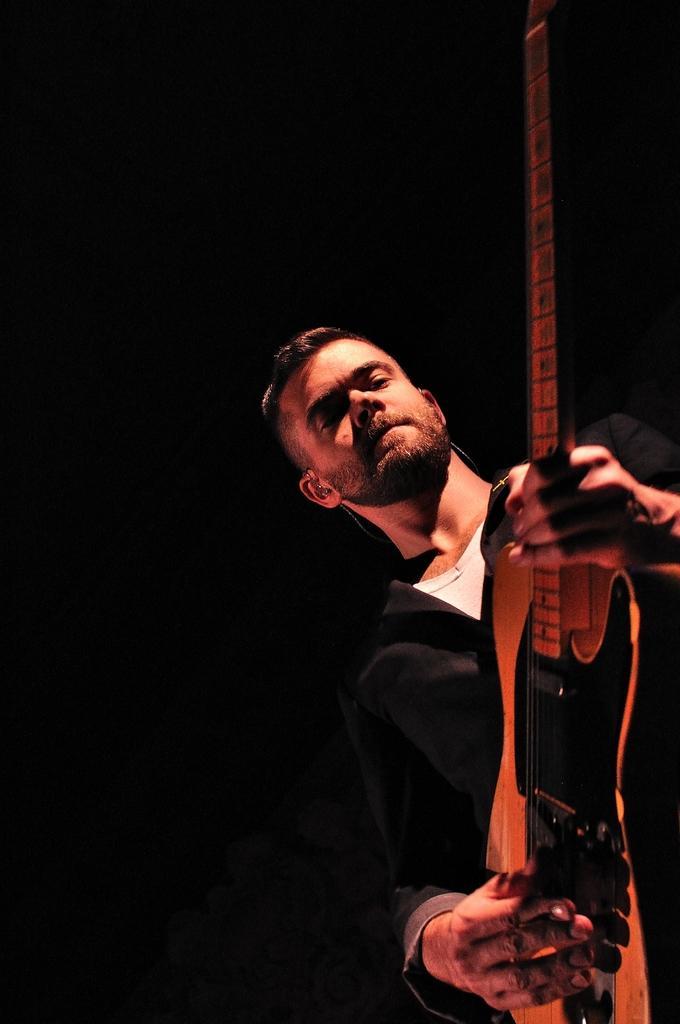Describe this image in one or two sentences. In this picture we can see a man in black and white dress holding a guitar and playing it. 